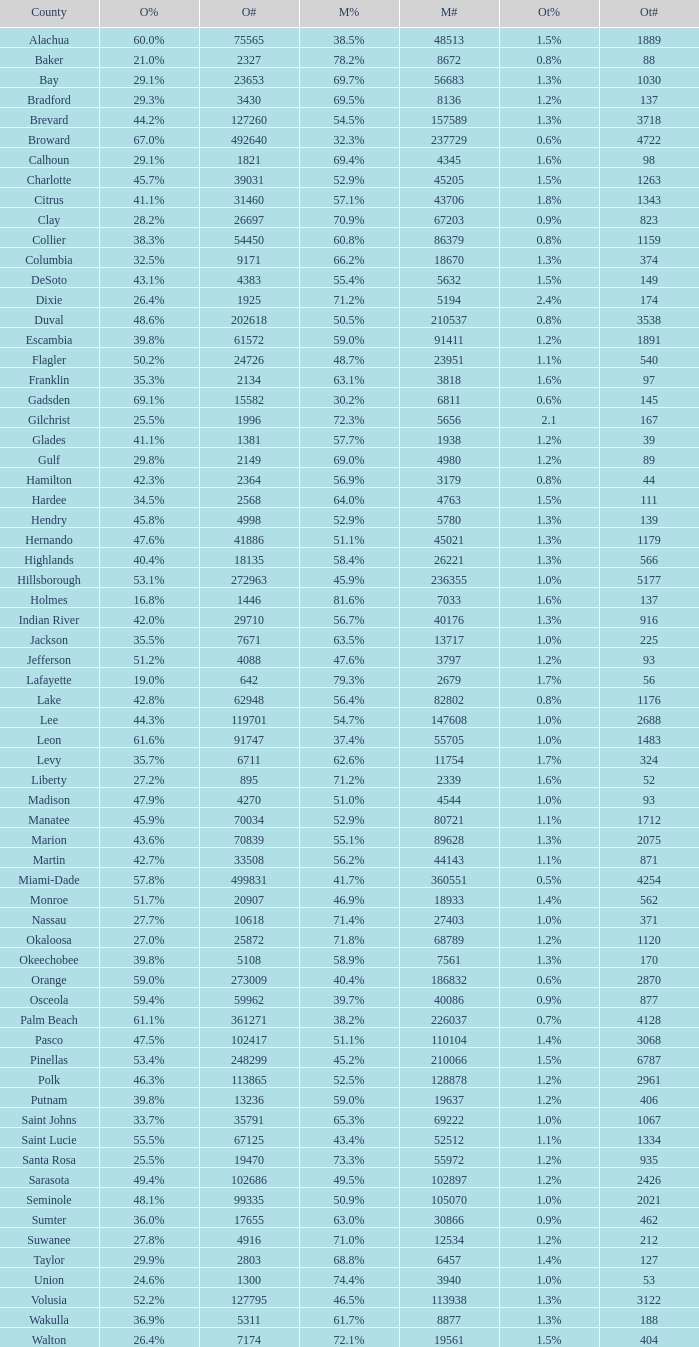How many numbers were recorded under McCain when Obama had 27.2% voters? 1.0. 